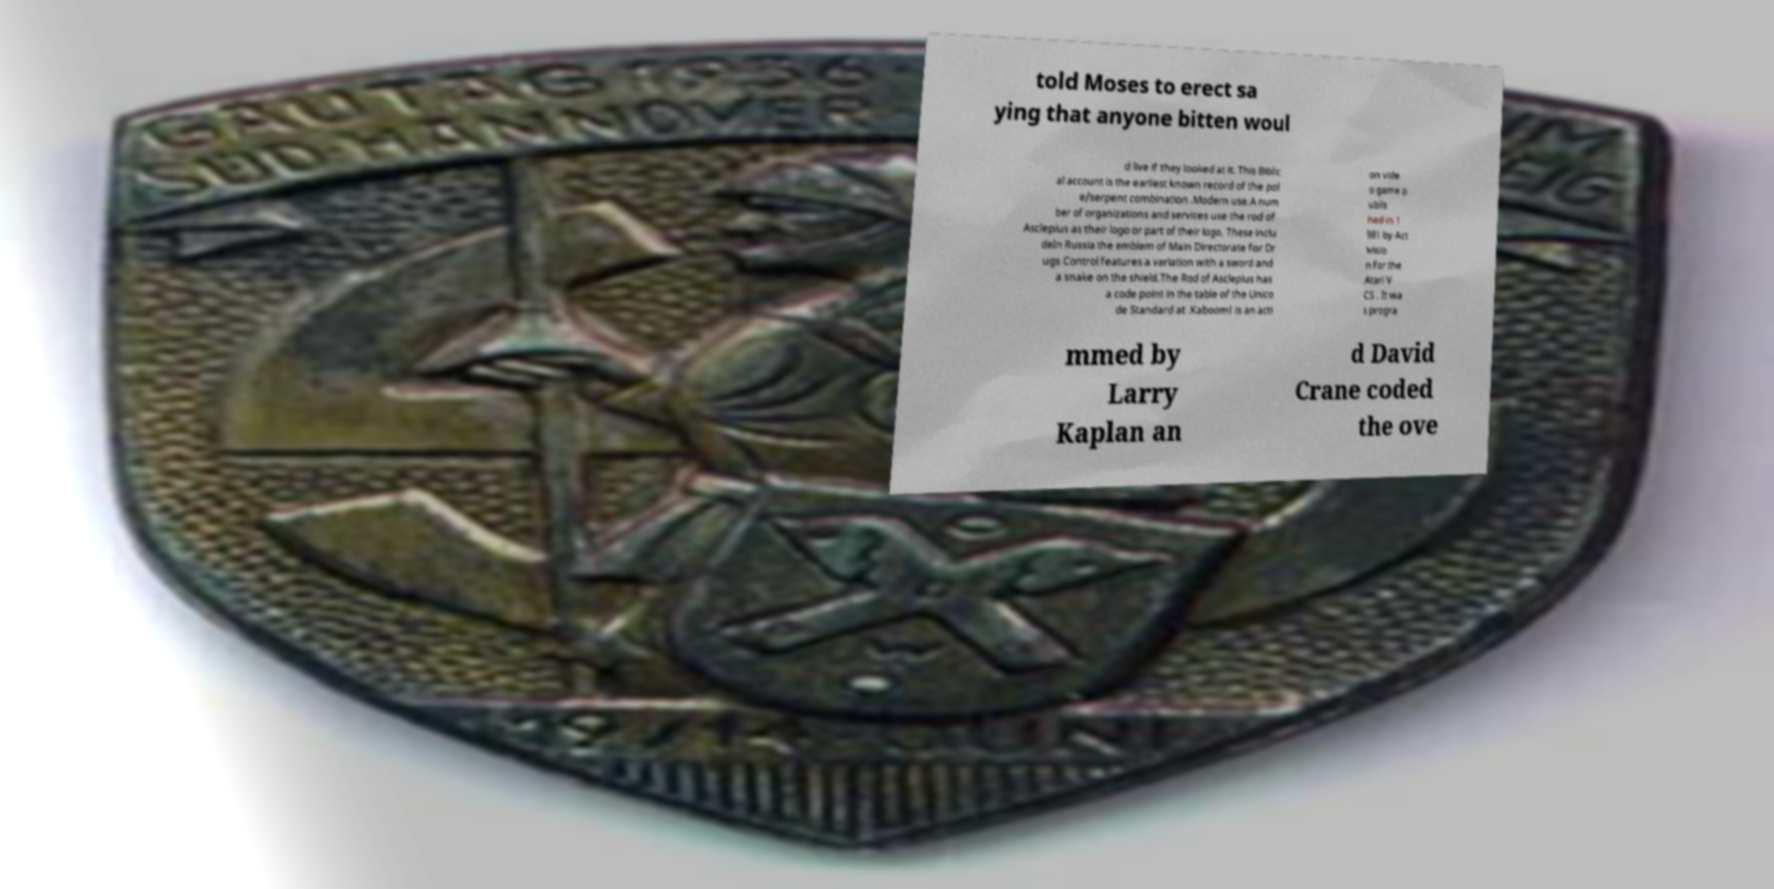Could you assist in decoding the text presented in this image and type it out clearly? told Moses to erect sa ying that anyone bitten woul d live if they looked at it. This Biblic al account is the earliest known record of the pol e/serpent combination .Modern use.A num ber of organizations and services use the rod of Asclepius as their logo or part of their logo. These inclu deIn Russia the emblem of Main Directorate for Dr ugs Control features a variation with a sword and a snake on the shield.The Rod of Asclepius has a code point in the table of the Unico de Standard at .Kaboom! is an acti on vide o game p ublis hed in 1 981 by Act ivisio n for the Atari V CS . It wa s progra mmed by Larry Kaplan an d David Crane coded the ove 